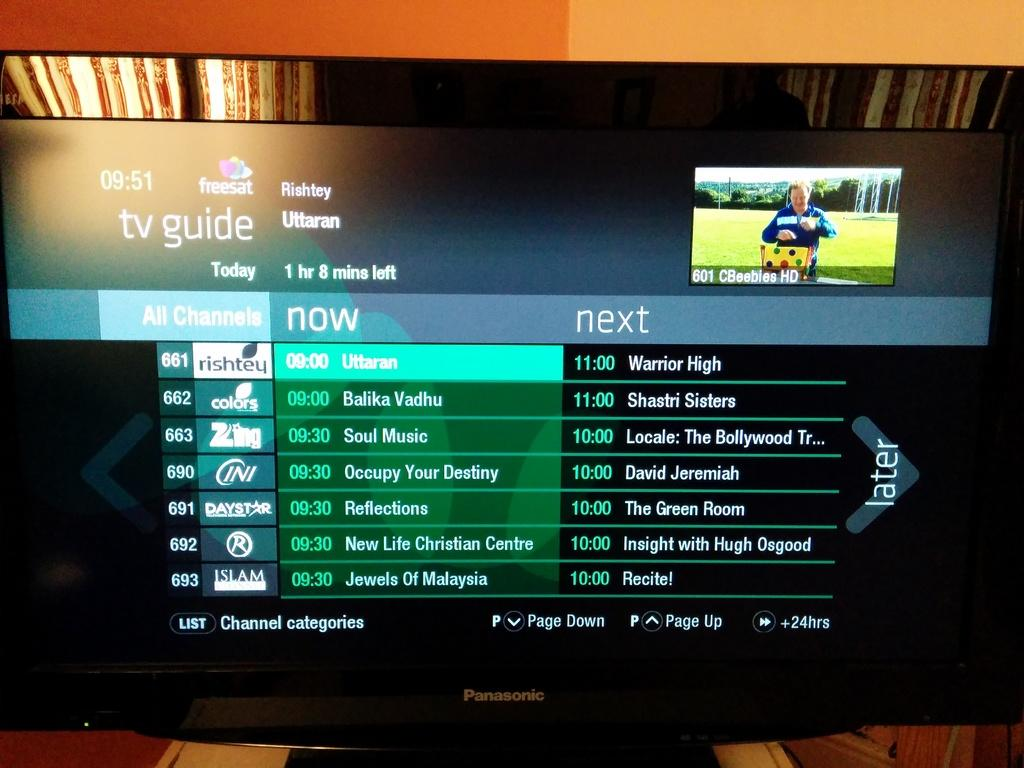Provide a one-sentence caption for the provided image. A TV guide is displaying a few different shows at 9, 10 and 11. 